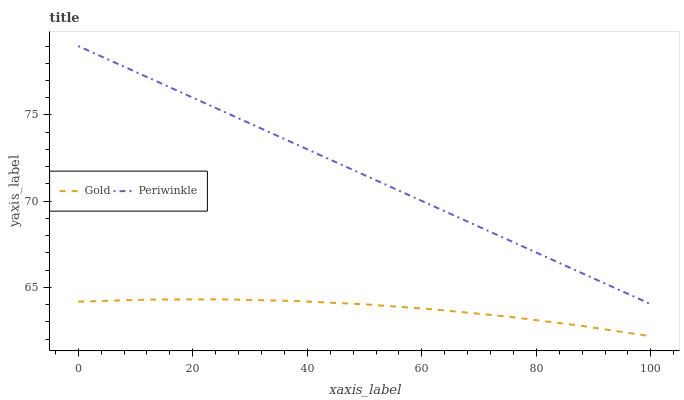Does Gold have the minimum area under the curve?
Answer yes or no. Yes. Does Periwinkle have the maximum area under the curve?
Answer yes or no. Yes. Does Gold have the maximum area under the curve?
Answer yes or no. No. Is Periwinkle the smoothest?
Answer yes or no. Yes. Is Gold the roughest?
Answer yes or no. Yes. Is Gold the smoothest?
Answer yes or no. No. Does Periwinkle have the highest value?
Answer yes or no. Yes. Does Gold have the highest value?
Answer yes or no. No. Is Gold less than Periwinkle?
Answer yes or no. Yes. Is Periwinkle greater than Gold?
Answer yes or no. Yes. Does Gold intersect Periwinkle?
Answer yes or no. No. 